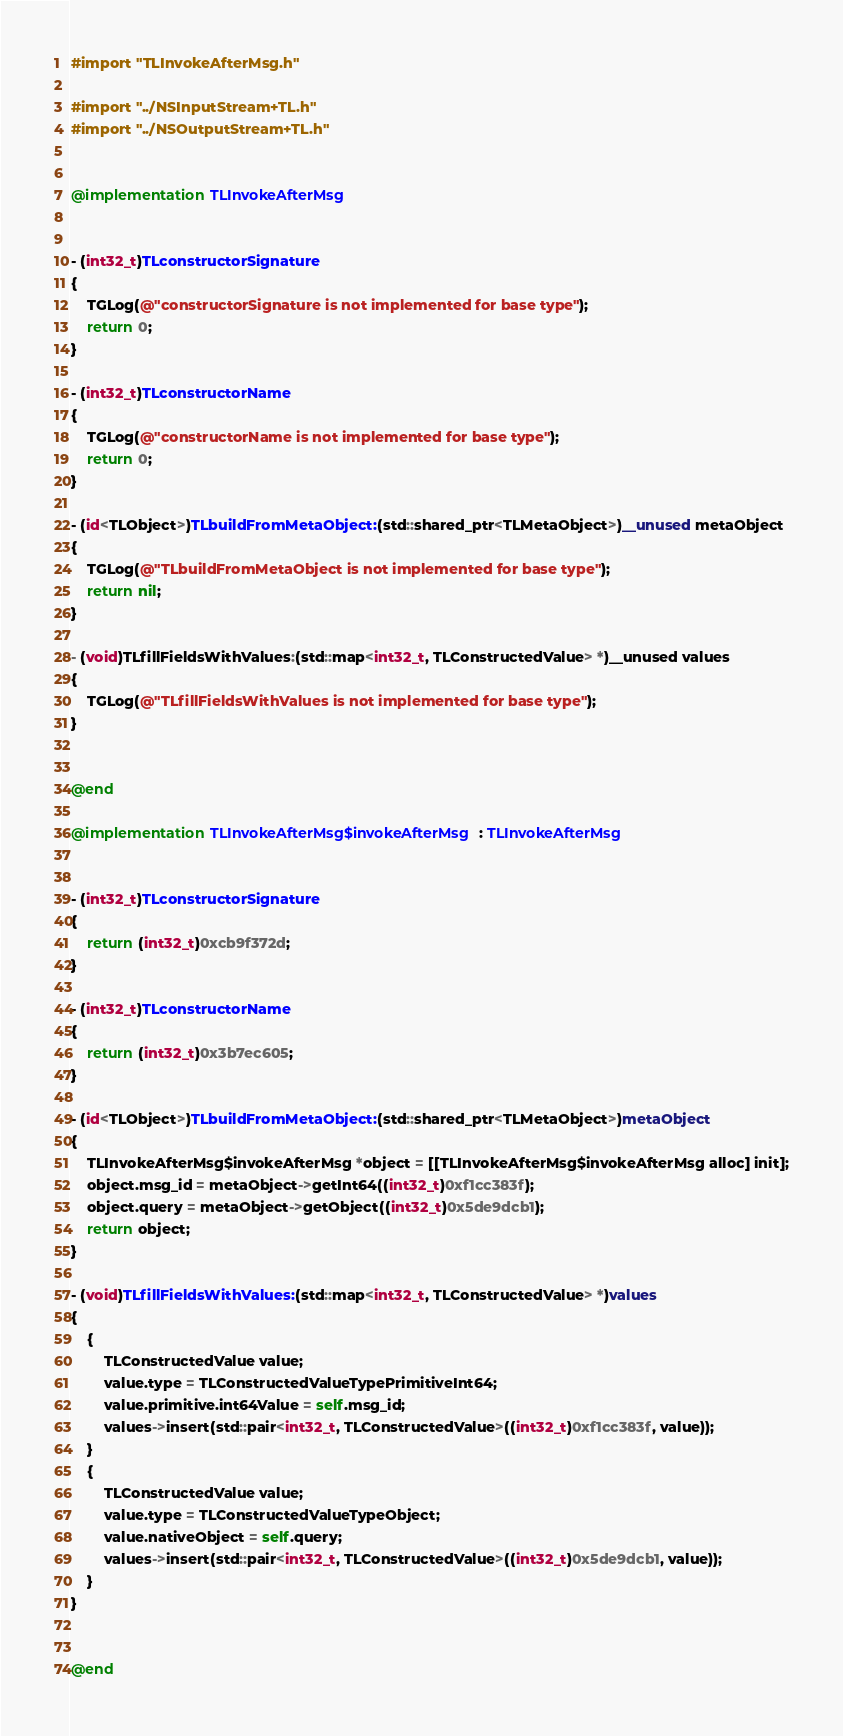Convert code to text. <code><loc_0><loc_0><loc_500><loc_500><_ObjectiveC_>#import "TLInvokeAfterMsg.h"

#import "../NSInputStream+TL.h"
#import "../NSOutputStream+TL.h"


@implementation TLInvokeAfterMsg


- (int32_t)TLconstructorSignature
{
    TGLog(@"constructorSignature is not implemented for base type");
    return 0;
}

- (int32_t)TLconstructorName
{
    TGLog(@"constructorName is not implemented for base type");
    return 0;
}

- (id<TLObject>)TLbuildFromMetaObject:(std::shared_ptr<TLMetaObject>)__unused metaObject
{
    TGLog(@"TLbuildFromMetaObject is not implemented for base type");
    return nil;
}

- (void)TLfillFieldsWithValues:(std::map<int32_t, TLConstructedValue> *)__unused values
{
    TGLog(@"TLfillFieldsWithValues is not implemented for base type");
}


@end

@implementation TLInvokeAfterMsg$invokeAfterMsg : TLInvokeAfterMsg


- (int32_t)TLconstructorSignature
{
    return (int32_t)0xcb9f372d;
}

- (int32_t)TLconstructorName
{
    return (int32_t)0x3b7ec605;
}

- (id<TLObject>)TLbuildFromMetaObject:(std::shared_ptr<TLMetaObject>)metaObject
{
    TLInvokeAfterMsg$invokeAfterMsg *object = [[TLInvokeAfterMsg$invokeAfterMsg alloc] init];
    object.msg_id = metaObject->getInt64((int32_t)0xf1cc383f);
    object.query = metaObject->getObject((int32_t)0x5de9dcb1);
    return object;
}

- (void)TLfillFieldsWithValues:(std::map<int32_t, TLConstructedValue> *)values
{
    {
        TLConstructedValue value;
        value.type = TLConstructedValueTypePrimitiveInt64;
        value.primitive.int64Value = self.msg_id;
        values->insert(std::pair<int32_t, TLConstructedValue>((int32_t)0xf1cc383f, value));
    }
    {
        TLConstructedValue value;
        value.type = TLConstructedValueTypeObject;
        value.nativeObject = self.query;
        values->insert(std::pair<int32_t, TLConstructedValue>((int32_t)0x5de9dcb1, value));
    }
}


@end

</code> 